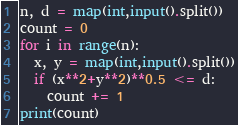<code> <loc_0><loc_0><loc_500><loc_500><_Python_>n, d = map(int,input().split())
count = 0
for i in range(n):
  x, y = map(int,input().split())
  if (x**2+y**2)**0.5 <= d:
    count += 1
print(count)</code> 